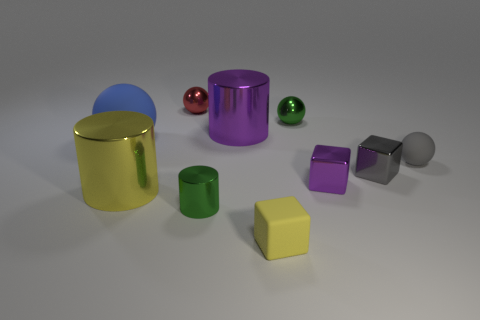How many objects in the image have a cylindrical shape? There are four objects with a cylindrical shape in the image. 